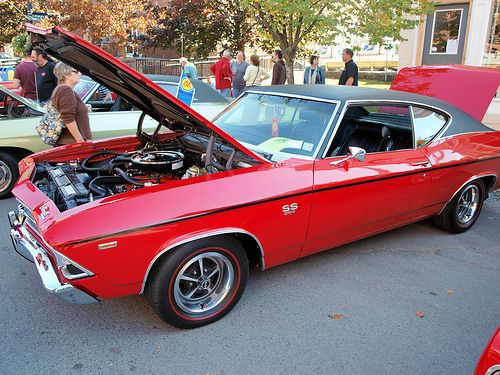<image>
Is the car behind the hood? Yes. From this viewpoint, the car is positioned behind the hood, with the hood partially or fully occluding the car. 